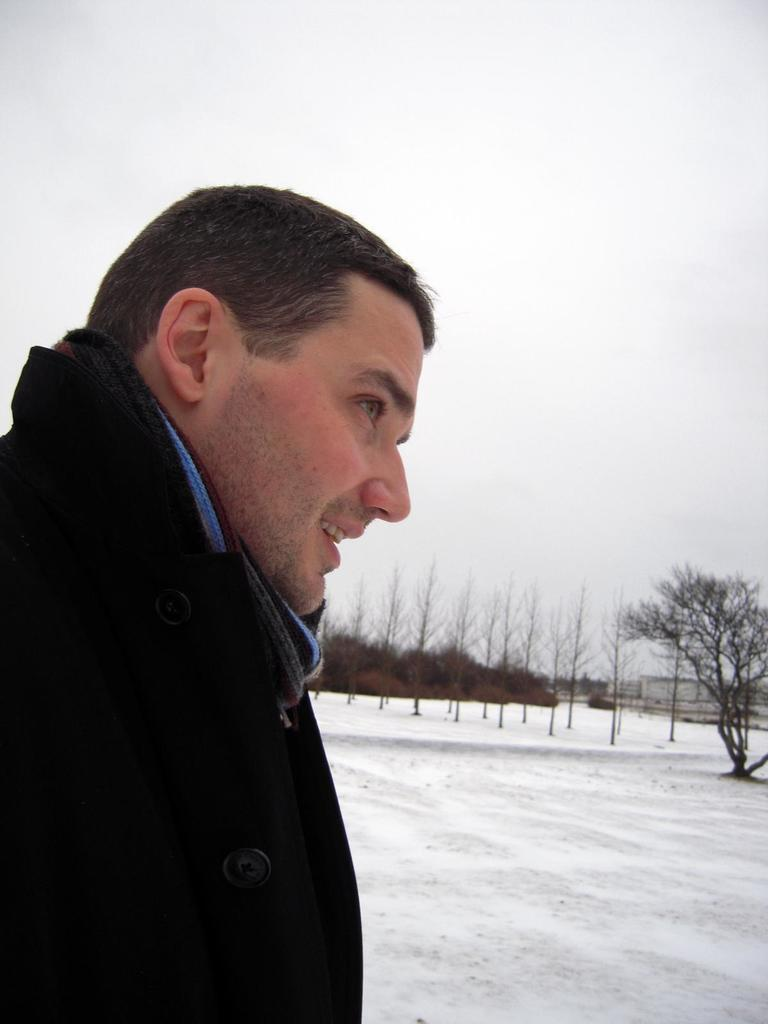Who is present in the image? There is a man in the image. What is the man's facial expression? The man is smiling. What can be seen in the background of the image? There are buildings, snow, trees, and the sky visible in the background of the image. What type of tin can be seen in the man's hand in the image? There is no tin present in the man's hand or in the image. 